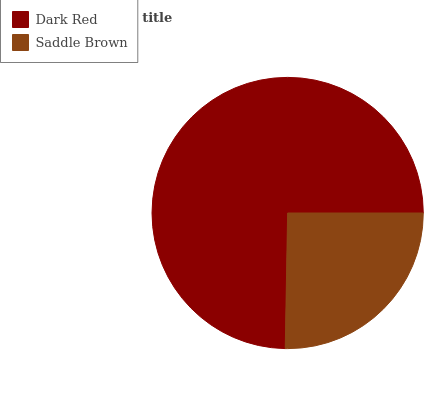Is Saddle Brown the minimum?
Answer yes or no. Yes. Is Dark Red the maximum?
Answer yes or no. Yes. Is Saddle Brown the maximum?
Answer yes or no. No. Is Dark Red greater than Saddle Brown?
Answer yes or no. Yes. Is Saddle Brown less than Dark Red?
Answer yes or no. Yes. Is Saddle Brown greater than Dark Red?
Answer yes or no. No. Is Dark Red less than Saddle Brown?
Answer yes or no. No. Is Dark Red the high median?
Answer yes or no. Yes. Is Saddle Brown the low median?
Answer yes or no. Yes. Is Saddle Brown the high median?
Answer yes or no. No. Is Dark Red the low median?
Answer yes or no. No. 